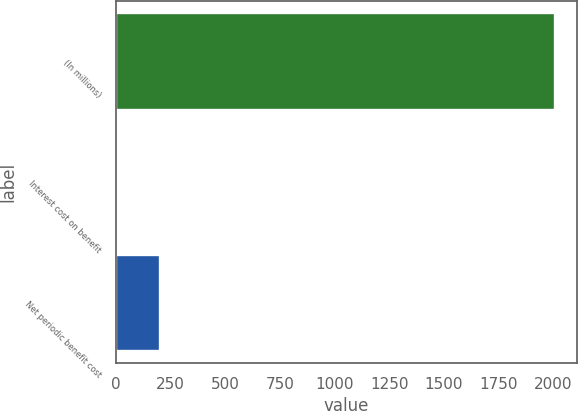<chart> <loc_0><loc_0><loc_500><loc_500><bar_chart><fcel>(In millions)<fcel>Interest cost on benefit<fcel>Net periodic benefit cost<nl><fcel>2008<fcel>0.6<fcel>201.34<nl></chart> 